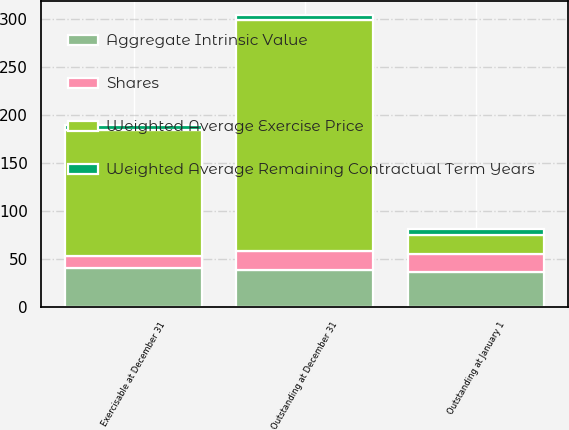<chart> <loc_0><loc_0><loc_500><loc_500><stacked_bar_chart><ecel><fcel>Outstanding at January 1<fcel>Outstanding at December 31<fcel>Exercisable at December 31<nl><fcel>Shares<fcel>19.5<fcel>18.9<fcel>12.1<nl><fcel>Aggregate Intrinsic Value<fcel>35.96<fcel>38.85<fcel>40.56<nl><fcel>Weighted Average Remaining Contractual Term Years<fcel>6.7<fcel>5.3<fcel>5<nl><fcel>Weighted Average Exercise Price<fcel>19.5<fcel>241<fcel>132<nl></chart> 